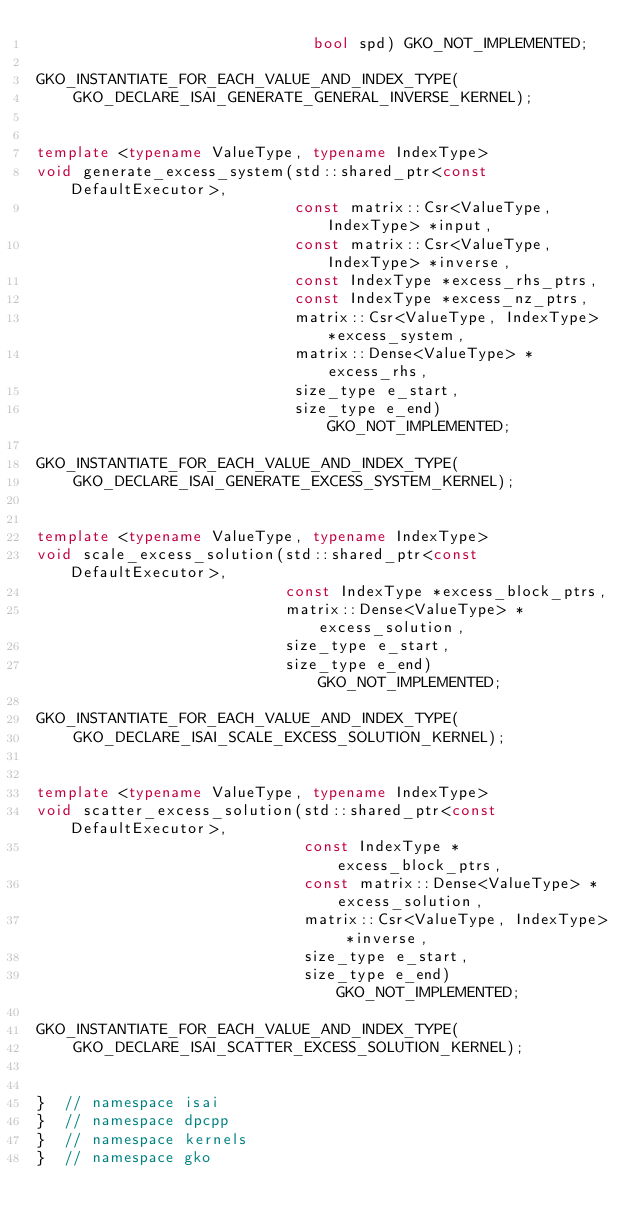Convert code to text. <code><loc_0><loc_0><loc_500><loc_500><_C++_>                              bool spd) GKO_NOT_IMPLEMENTED;

GKO_INSTANTIATE_FOR_EACH_VALUE_AND_INDEX_TYPE(
    GKO_DECLARE_ISAI_GENERATE_GENERAL_INVERSE_KERNEL);


template <typename ValueType, typename IndexType>
void generate_excess_system(std::shared_ptr<const DefaultExecutor>,
                            const matrix::Csr<ValueType, IndexType> *input,
                            const matrix::Csr<ValueType, IndexType> *inverse,
                            const IndexType *excess_rhs_ptrs,
                            const IndexType *excess_nz_ptrs,
                            matrix::Csr<ValueType, IndexType> *excess_system,
                            matrix::Dense<ValueType> *excess_rhs,
                            size_type e_start,
                            size_type e_end) GKO_NOT_IMPLEMENTED;

GKO_INSTANTIATE_FOR_EACH_VALUE_AND_INDEX_TYPE(
    GKO_DECLARE_ISAI_GENERATE_EXCESS_SYSTEM_KERNEL);


template <typename ValueType, typename IndexType>
void scale_excess_solution(std::shared_ptr<const DefaultExecutor>,
                           const IndexType *excess_block_ptrs,
                           matrix::Dense<ValueType> *excess_solution,
                           size_type e_start,
                           size_type e_end) GKO_NOT_IMPLEMENTED;

GKO_INSTANTIATE_FOR_EACH_VALUE_AND_INDEX_TYPE(
    GKO_DECLARE_ISAI_SCALE_EXCESS_SOLUTION_KERNEL);


template <typename ValueType, typename IndexType>
void scatter_excess_solution(std::shared_ptr<const DefaultExecutor>,
                             const IndexType *excess_block_ptrs,
                             const matrix::Dense<ValueType> *excess_solution,
                             matrix::Csr<ValueType, IndexType> *inverse,
                             size_type e_start,
                             size_type e_end) GKO_NOT_IMPLEMENTED;

GKO_INSTANTIATE_FOR_EACH_VALUE_AND_INDEX_TYPE(
    GKO_DECLARE_ISAI_SCATTER_EXCESS_SOLUTION_KERNEL);


}  // namespace isai
}  // namespace dpcpp
}  // namespace kernels
}  // namespace gko
</code> 